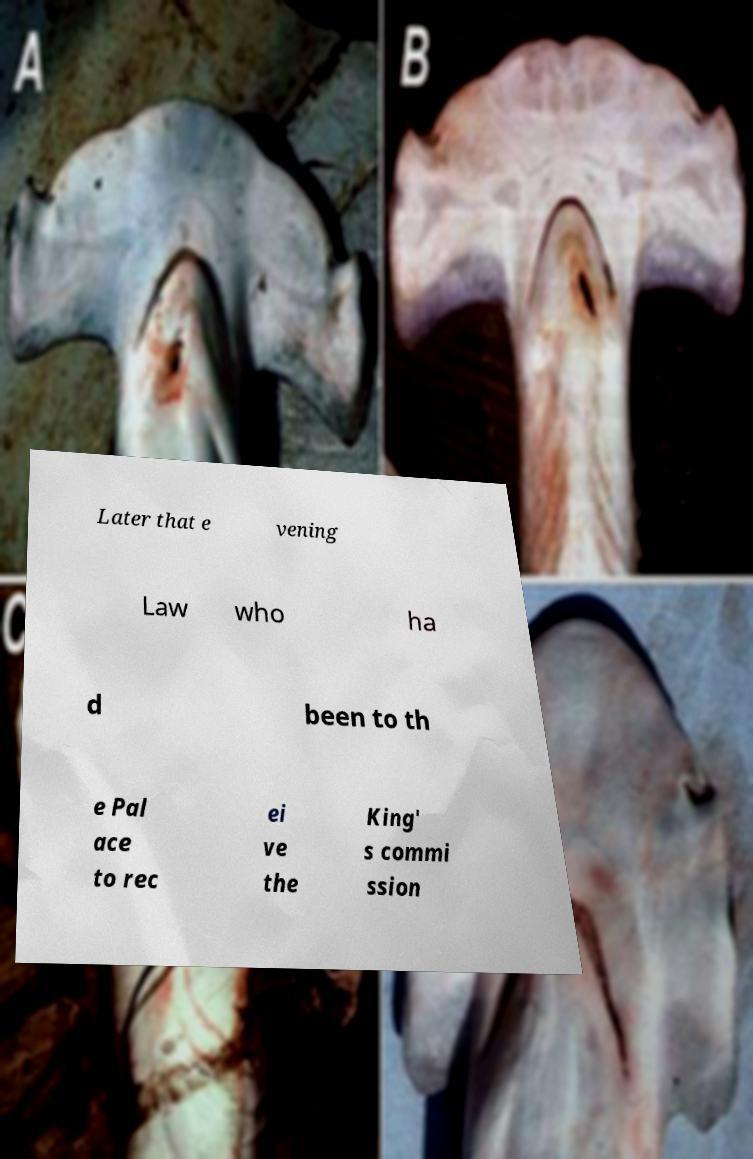Please read and relay the text visible in this image. What does it say? Later that e vening Law who ha d been to th e Pal ace to rec ei ve the King' s commi ssion 